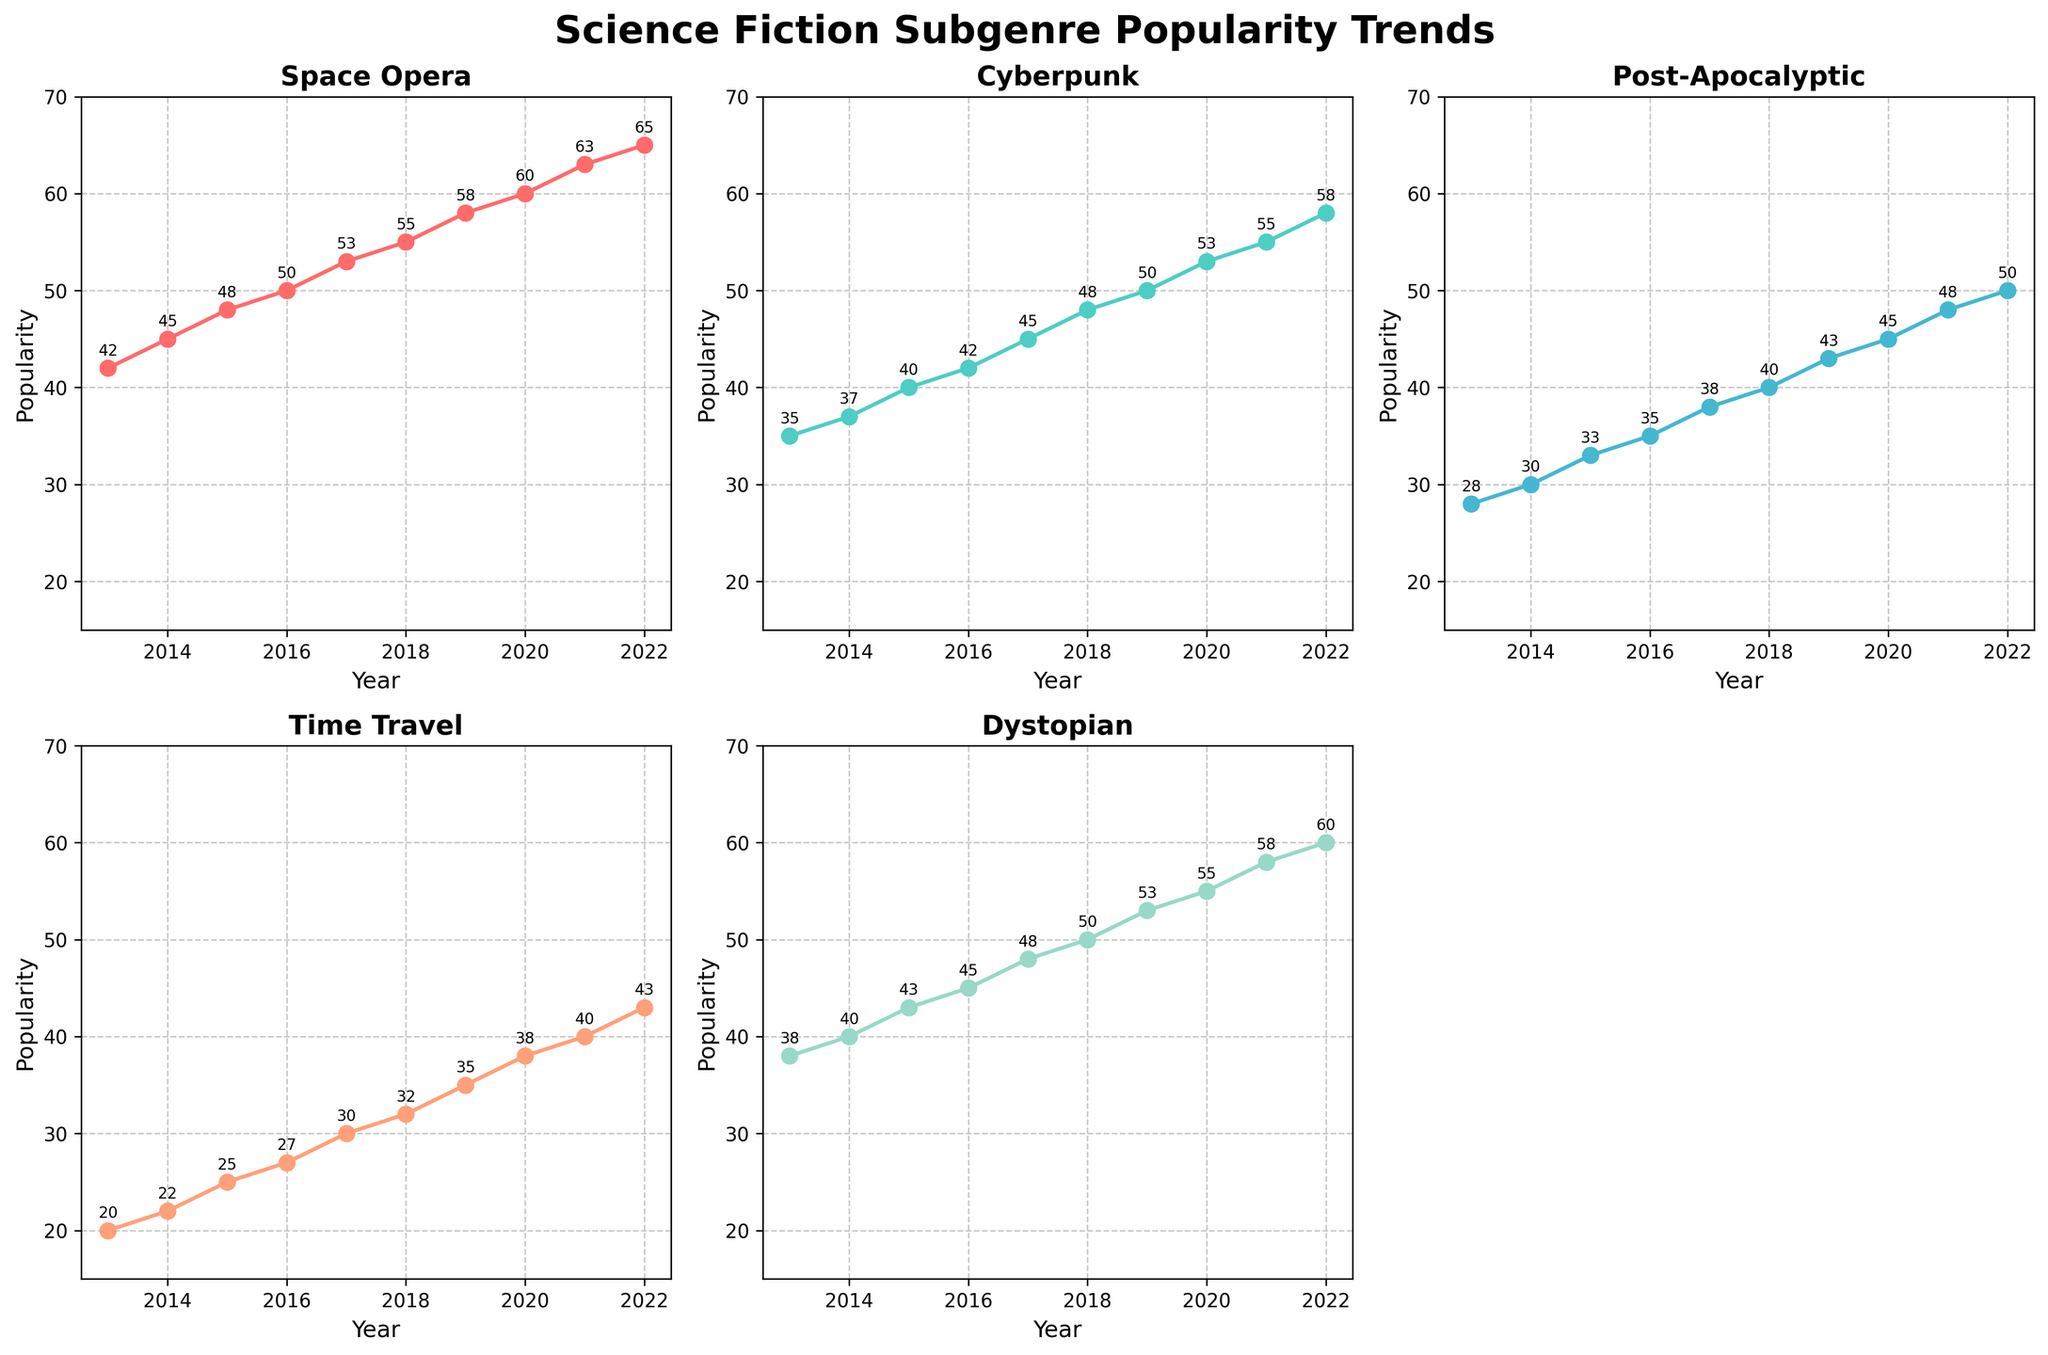what year does the Dystopian genre hit 50 in popularity? Look at the subplot for the Dystopian genre (bottom left). In 2022, the annotated value reaches 50.
Answer: 2022 Which subgenre consistently increased its popularity every year? Check each subgenre's subplot's trend line. Space Opera increases every year without a decline.
Answer: Space Opera What's the highest recorded popularity for Cyberpunk? On the Cyberpunk subplot, locate the highest point on the y-axis. The highest value annotated is 58 in 2022.
Answer: 58 How many data points are plotted for each subgenre? Each subplot has data points for each year from 2013 to 2022. Counting these, we get 10 data points.
Answer: 10 Compare the popularity of Space Opera and Post-Apocalyptic in 2016. Which is higher? Find the respective points for 2016 in both subplots. Space Opera is 50, and Post-Apocalyptic is 35. Space Opera is higher.
Answer: Space Opera What's the average popularity of Time Travel over the past decade? Add Time Travel popularity values from 2013 to 2022 and divide by the number of years (10). (20+22+25+27+30+32+35+38+40+43)/10 = 31.2
Answer: 31.2 Which subgenre's popularity surpassed 60 first? Compare trend lines for each subplot to see which crosses 60 first. Space Opera hits 63 in 2021 while others are below 60.
Answer: Space Opera In which year did Post-Apocalyptic see the highest annual increase in popularity? Calculate annual increases for Post-Apocalyptic in each year. The largest jump is from 42 (2018) to 45 (2019), an increase of 3.
Answer: 2019 Which two subgenres have the closest popularity values in 2019? Compare the 2019 values in each subplot. Cyberpunk (50) and Dystopian (53) values are closest, a difference of 3.
Answer: Cyberpunk and Dystopian 